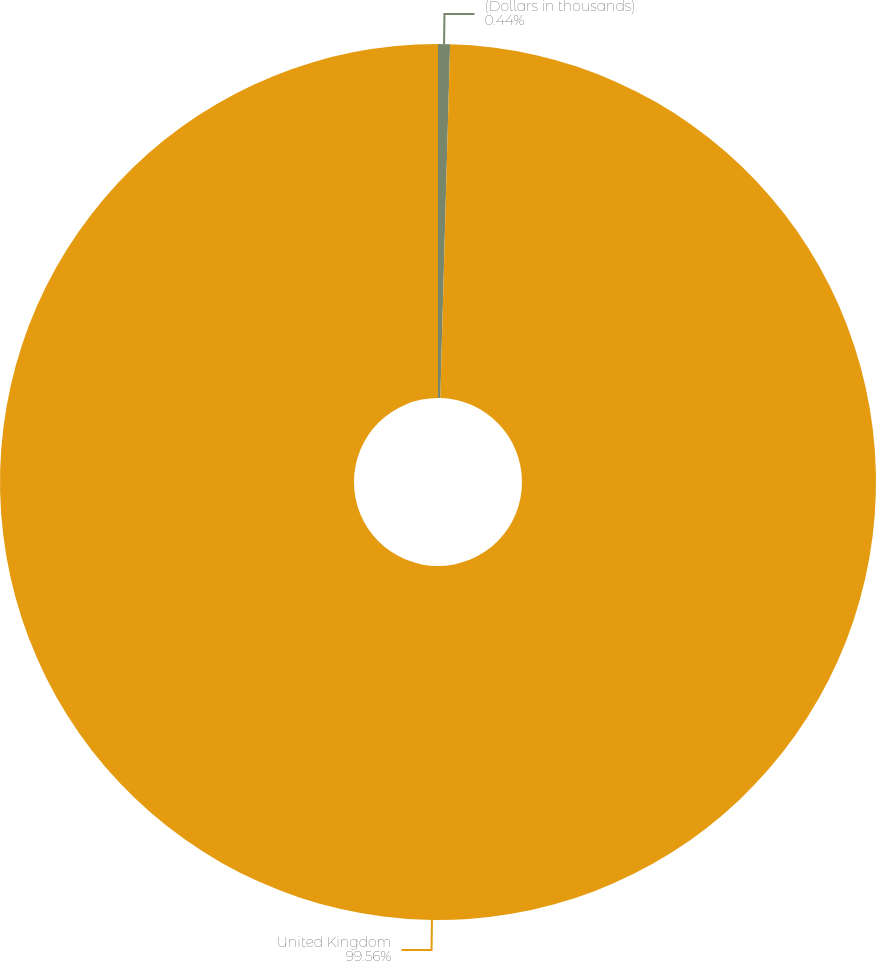<chart> <loc_0><loc_0><loc_500><loc_500><pie_chart><fcel>(Dollars in thousands)<fcel>United Kingdom<nl><fcel>0.44%<fcel>99.56%<nl></chart> 